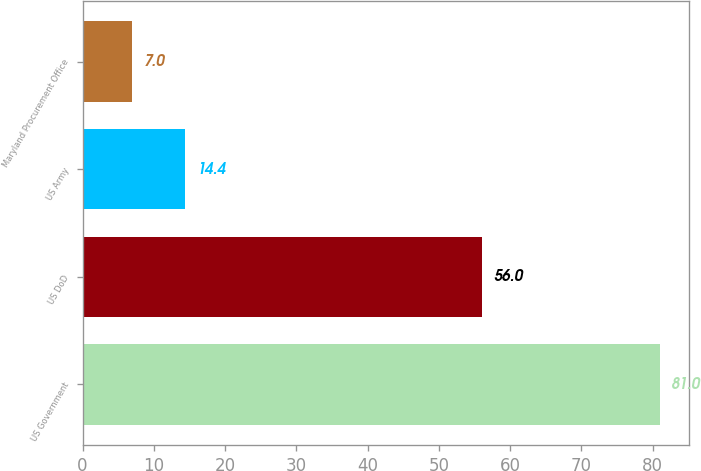Convert chart to OTSL. <chart><loc_0><loc_0><loc_500><loc_500><bar_chart><fcel>US Government<fcel>US DoD<fcel>US Army<fcel>Maryland Procurement Office<nl><fcel>81<fcel>56<fcel>14.4<fcel>7<nl></chart> 